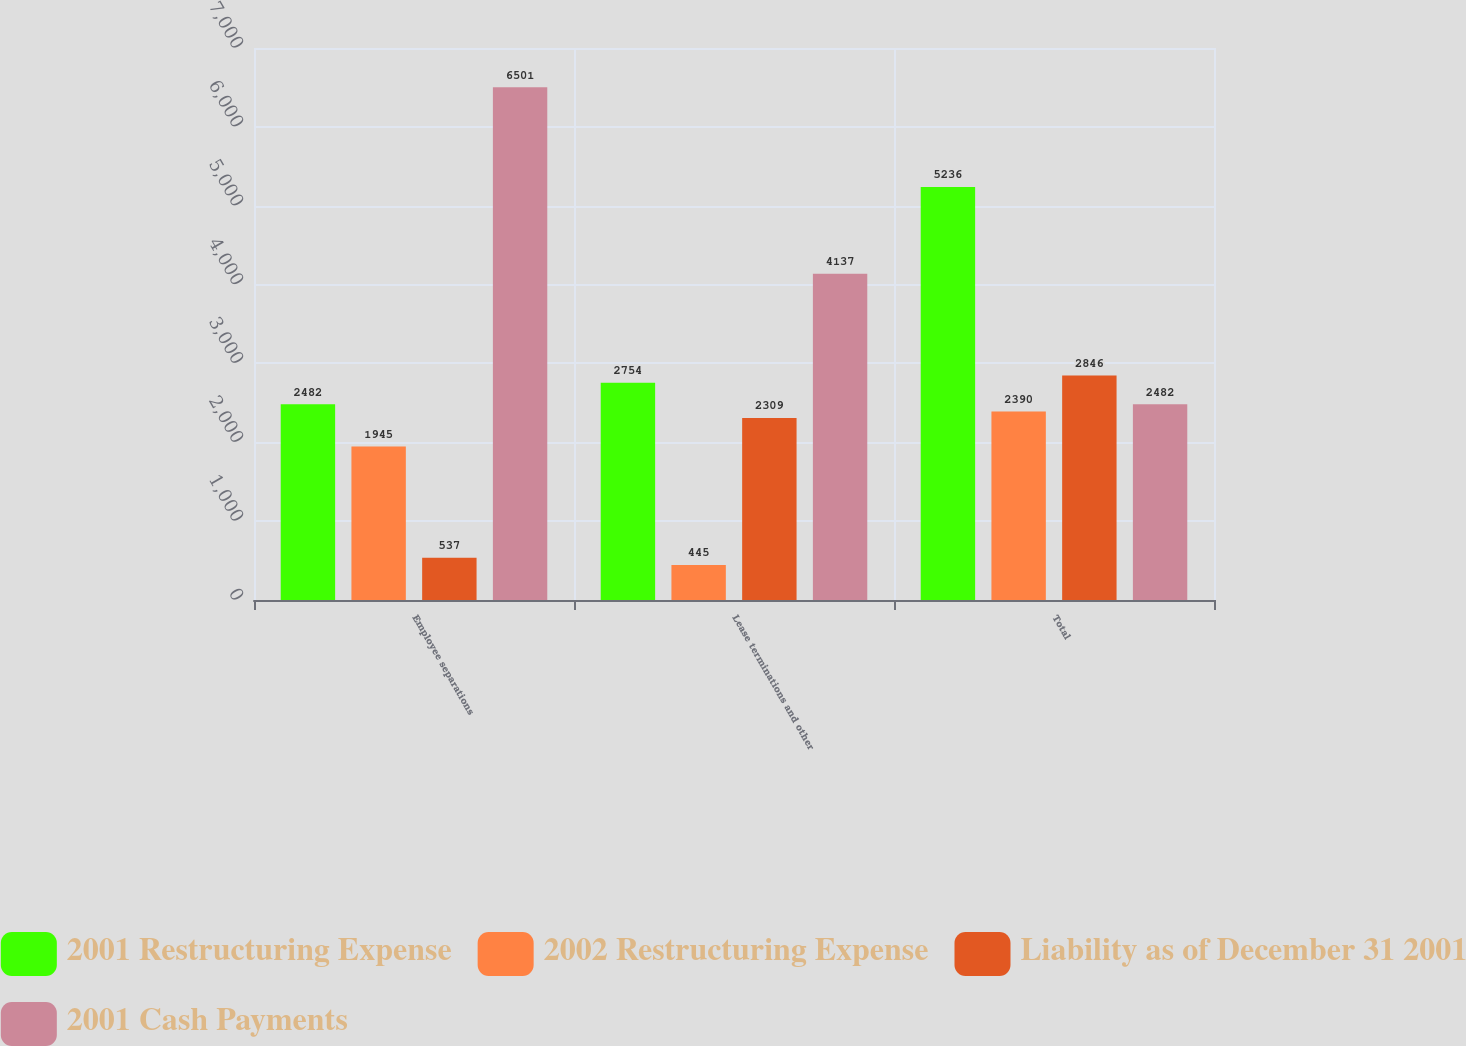Convert chart to OTSL. <chart><loc_0><loc_0><loc_500><loc_500><stacked_bar_chart><ecel><fcel>Employee separations<fcel>Lease terminations and other<fcel>Total<nl><fcel>2001 Restructuring Expense<fcel>2482<fcel>2754<fcel>5236<nl><fcel>2002 Restructuring Expense<fcel>1945<fcel>445<fcel>2390<nl><fcel>Liability as of December 31 2001<fcel>537<fcel>2309<fcel>2846<nl><fcel>2001 Cash Payments<fcel>6501<fcel>4137<fcel>2482<nl></chart> 